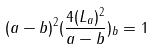Convert formula to latex. <formula><loc_0><loc_0><loc_500><loc_500>( a - b ) ^ { 2 } ( \frac { 4 ( L _ { a } ) ^ { 2 } } { a - b } ) _ { b } = 1</formula> 